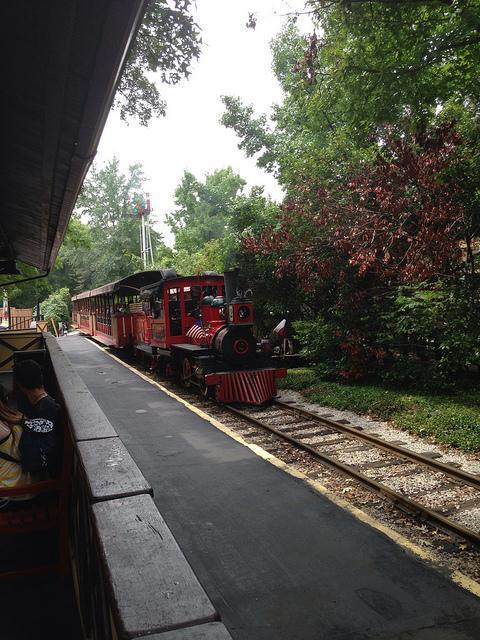How many people are visible?
Give a very brief answer. 2. 